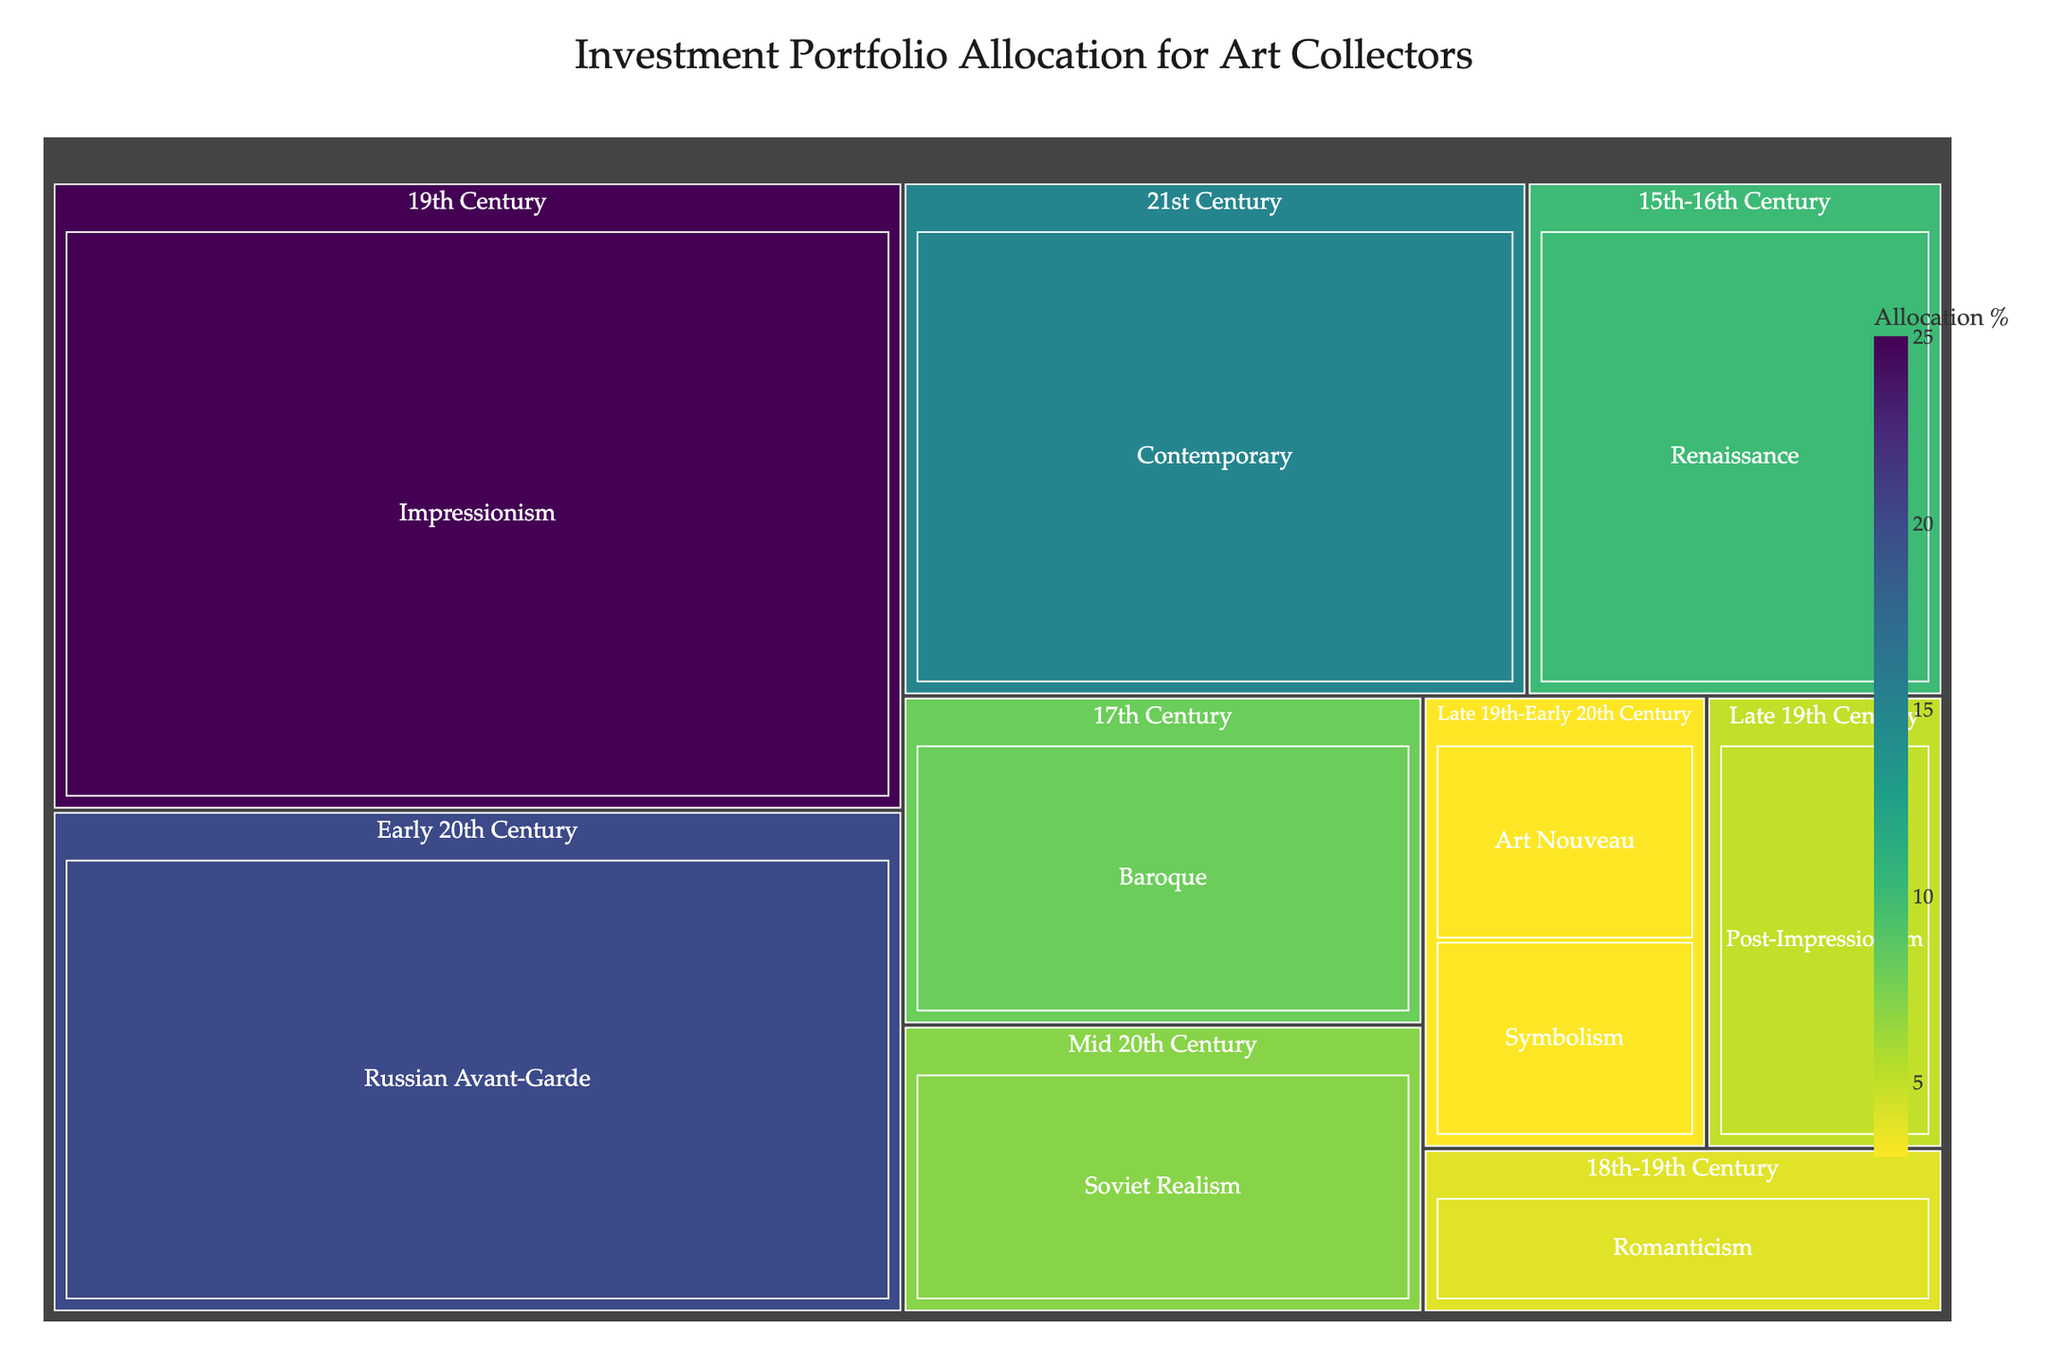What is the title of the Treemap? The title of the Treemap is located at the top of the figure in bold capital letters.
Answer: Investment Portfolio Allocation for Art Collectors Which art movement has the largest allocation percentage in the portfolio? Identify the largest block in the Treemap; the Treemap color gradient and size make the relative proportions visible.
Answer: Impressionism How much of the portfolio is allocated to Russian Avant-Garde art? Look at the size of the block labeled 'Russian Avant-Garde' and check the allocation percentage either visually or through hover data.
Answer: 20% What is the combined allocation percentage of Renaissance and Baroque art movements? Locate the Renaissance and Baroque blocks, note their individual percentages, and sum them.
Answer: 10% + 8% = 18% Which time period has the highest overall art allocation? Observe the largest top-level block that includes all sub-blocks. It represents the time period with the highest total allocation.
Answer: 19th Century Compare the allocation percentages between Contemporary and Soviet Realism. Which is higher? Find the blocks for Contemporary and Soviet Realism and compare their sizes and numerical values.
Answer: Contemporary What percentage is allocated to art movements from the Late 19th-Early 20th Century combined? Identify all blocks within the 'Late 19th-Early 20th Century' period and sum their allocation percentages.
Answer: 5% + 3% + 3% = 11% How does the allocation to the 15th-16th Century period compare to the 17th Century? Compare the total allocation percentages for the blocks representing the 15th-16th Century and the 17th Century periods.
Answer: 10% vs. 8% What's the sum of the allocation percentages for the mid and early 20th Century? Sum the allocation percentages of all blocks fitting within these two periods.
Answer: 20% + 7% = 27% Identify two art movements from the 19th Century and their total allocation percentage. Look at the 19th Century period block, identify the sub-blocks labeled with art movements, and sum their percentages.
Answer: Impressionism 25% + Post-Impressionism 5% = 30% 